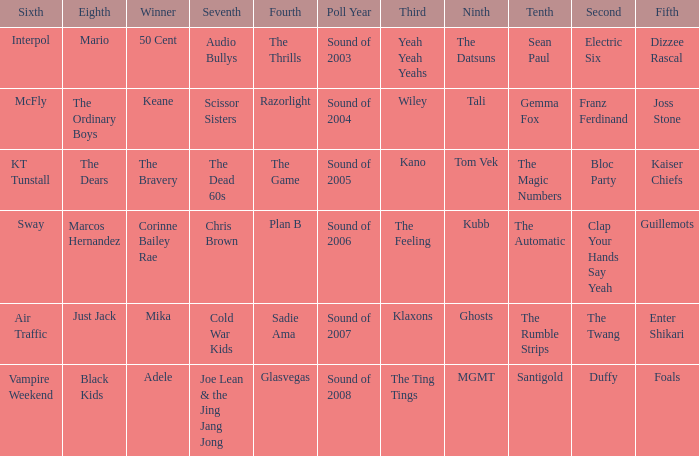Who was in 4th when in 6th is Air Traffic? Sadie Ama. 